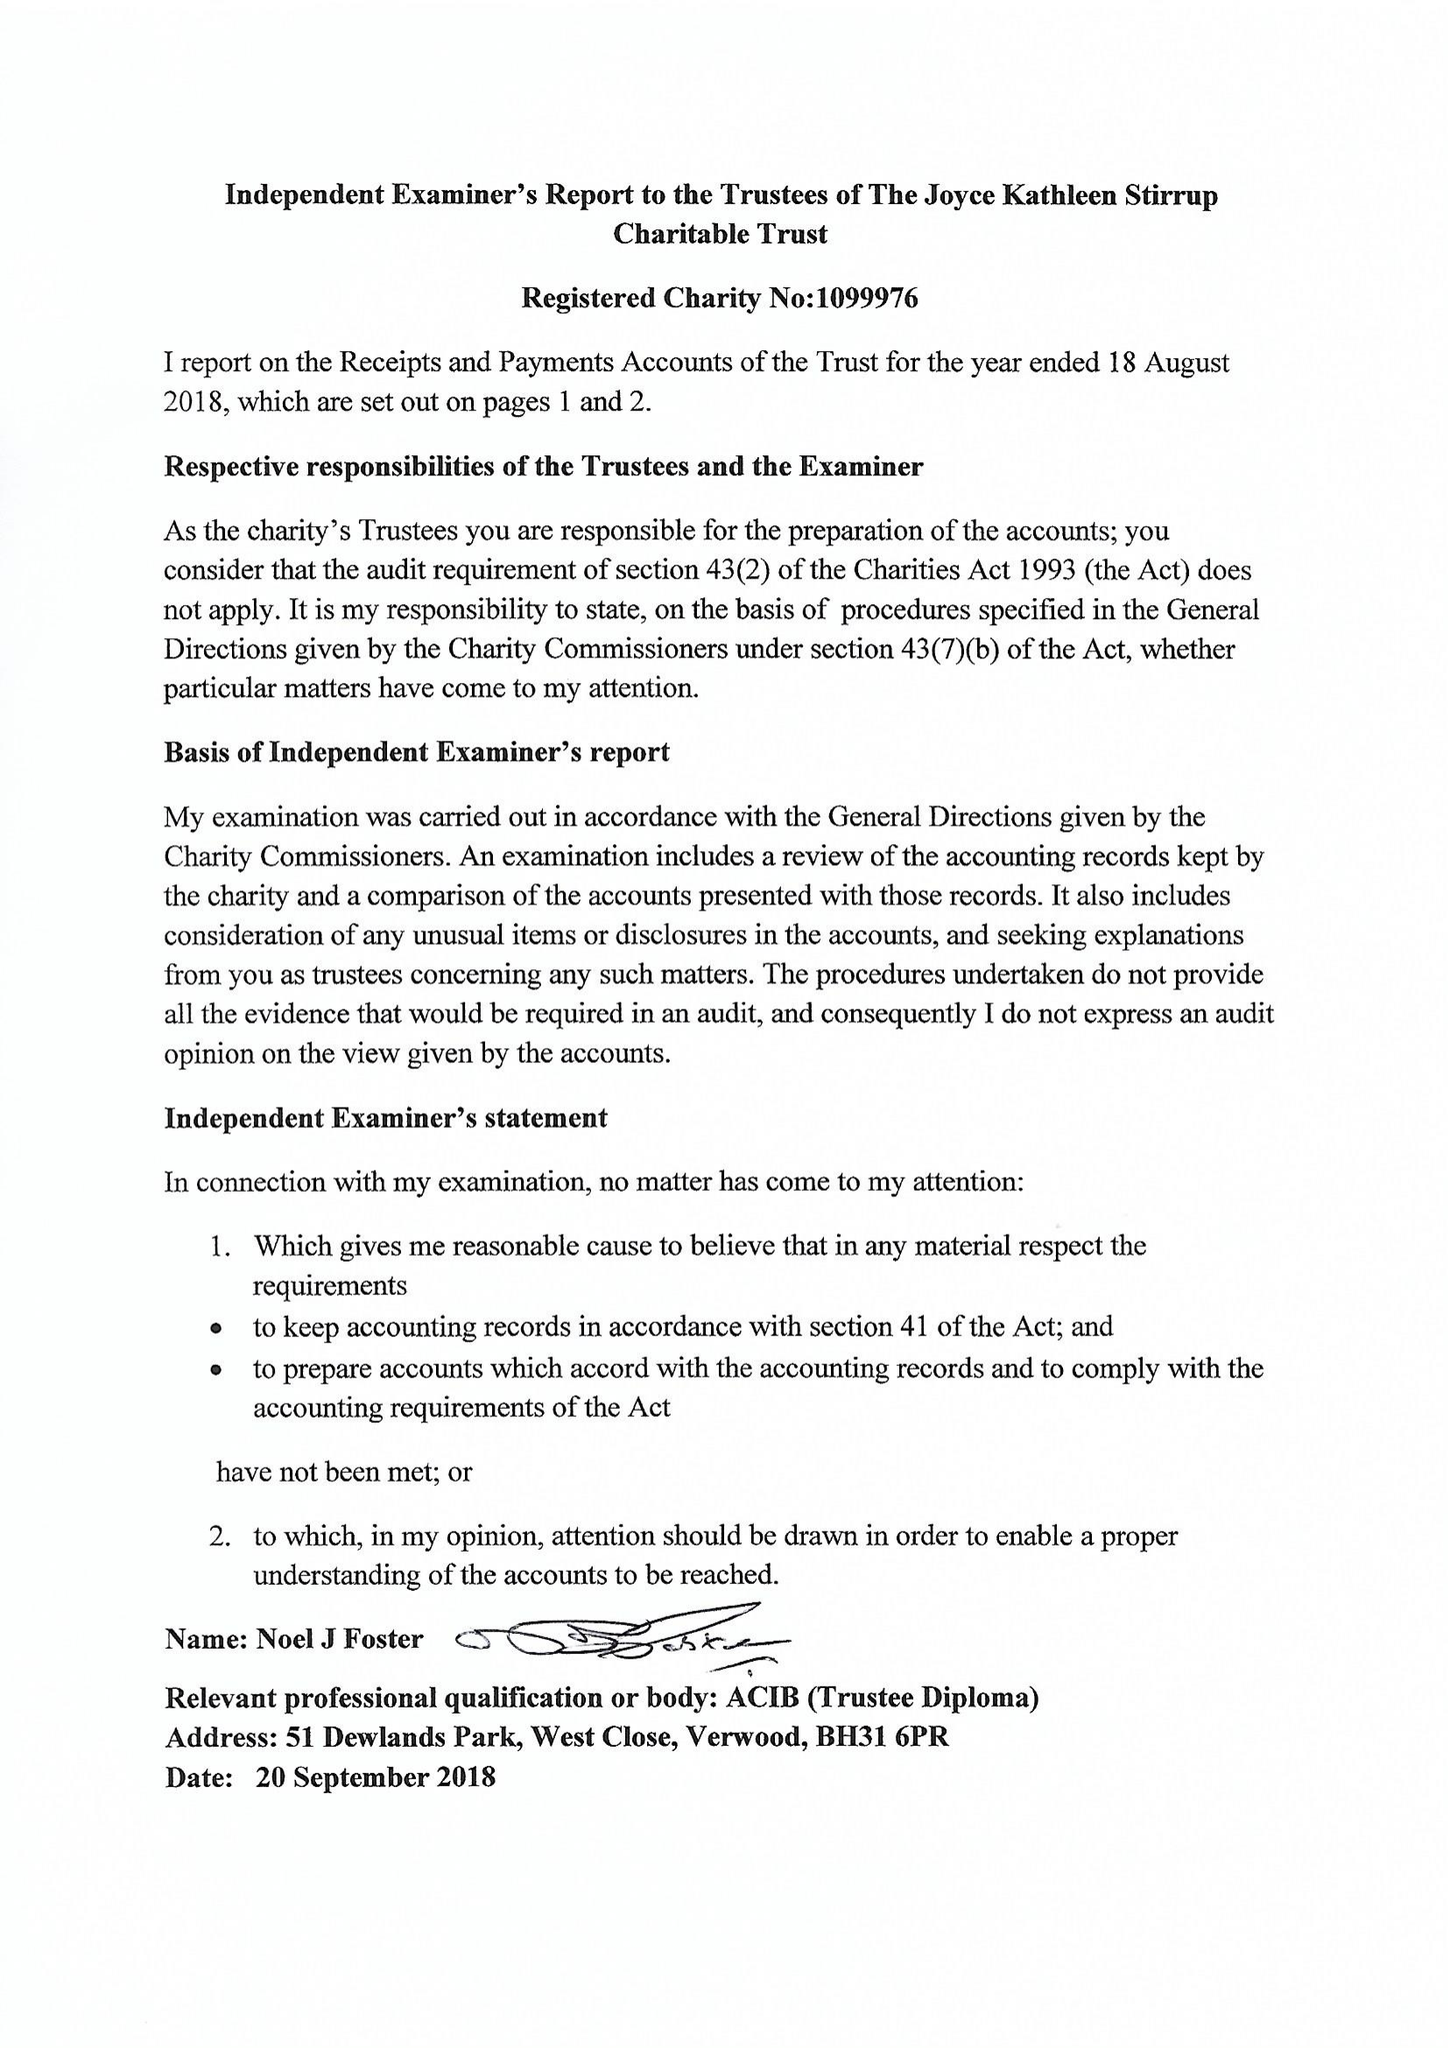What is the value for the address__street_line?
Answer the question using a single word or phrase. AVON STREET 